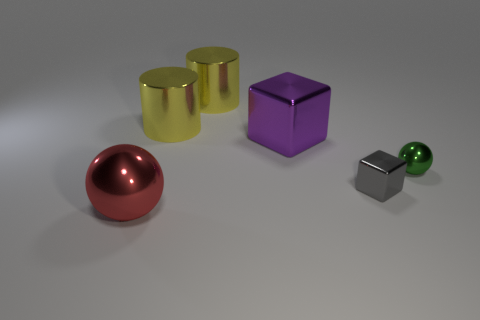Are there fewer big purple metal things that are in front of the small green metallic thing than small gray spheres?
Provide a succinct answer. No. What number of other things are the same size as the purple metal cube?
Keep it short and to the point. 3. There is a large metallic object that is in front of the tiny cube; does it have the same shape as the green metallic object?
Provide a short and direct response. Yes. Is the number of small shiny things in front of the tiny green shiny object greater than the number of brown cylinders?
Your answer should be compact. Yes. How many objects are in front of the large block and on the right side of the big red sphere?
Keep it short and to the point. 2. What material is the tiny gray block?
Ensure brevity in your answer.  Metal. Are there an equal number of tiny metallic things that are on the left side of the gray block and large blocks?
Make the answer very short. No. How many green shiny things have the same shape as the small gray thing?
Provide a succinct answer. 0. Is the large red metallic thing the same shape as the green object?
Provide a succinct answer. Yes. What number of things are either shiny blocks that are in front of the tiny green metallic sphere or small purple shiny spheres?
Provide a short and direct response. 1. 